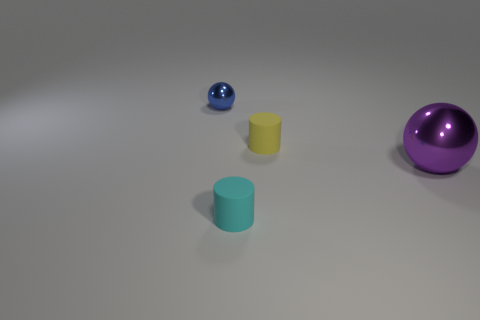Add 1 blue rubber objects. How many objects exist? 5 Subtract all tiny yellow things. Subtract all cyan metal spheres. How many objects are left? 3 Add 3 purple objects. How many purple objects are left? 4 Add 4 large green metallic blocks. How many large green metallic blocks exist? 4 Subtract 0 green cylinders. How many objects are left? 4 